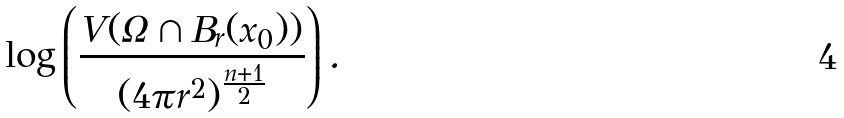<formula> <loc_0><loc_0><loc_500><loc_500>\log \left ( \frac { V ( \Omega \cap B _ { r } ( x _ { 0 } ) ) } { ( 4 \pi r ^ { 2 } ) ^ { \frac { n + 1 } { 2 } } } \right ) .</formula> 